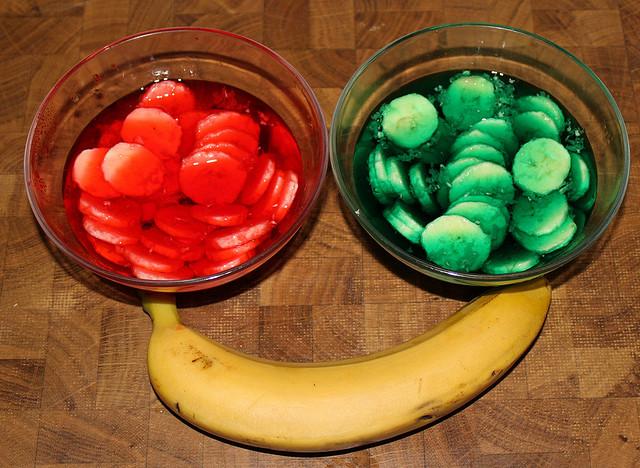Is the banana peeled?
Quick response, please. No. What color is dominant?
Concise answer only. Brown. What are the slices in the two bowls?
Write a very short answer. Bananas. 